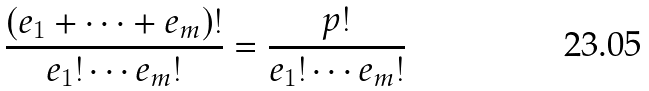<formula> <loc_0><loc_0><loc_500><loc_500>\frac { ( e _ { 1 } + \cdots + e _ { m } ) ! } { e _ { 1 } ! \cdots e _ { m } ! } = \frac { p ! } { e _ { 1 } ! \cdots e _ { m } ! }</formula> 